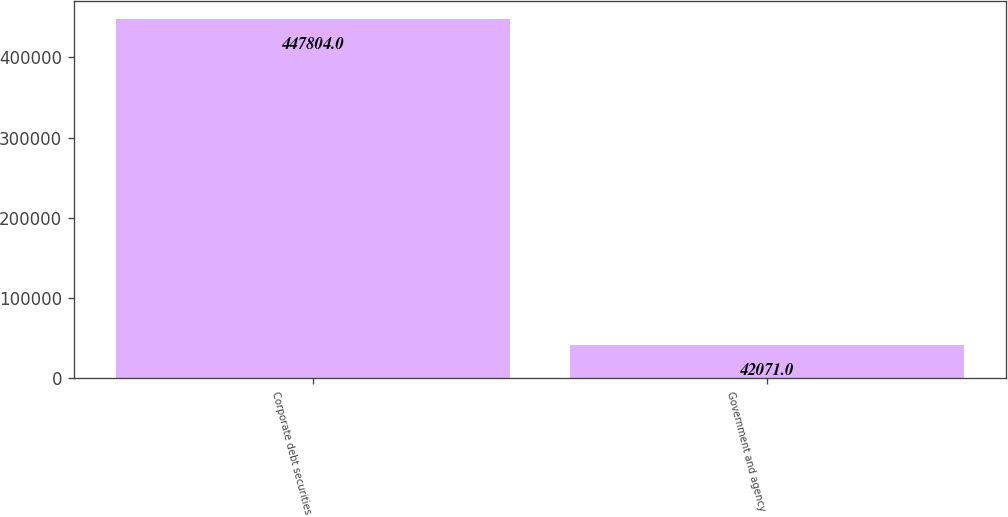Convert chart. <chart><loc_0><loc_0><loc_500><loc_500><bar_chart><fcel>Corporate debt securities<fcel>Government and agency<nl><fcel>447804<fcel>42071<nl></chart> 